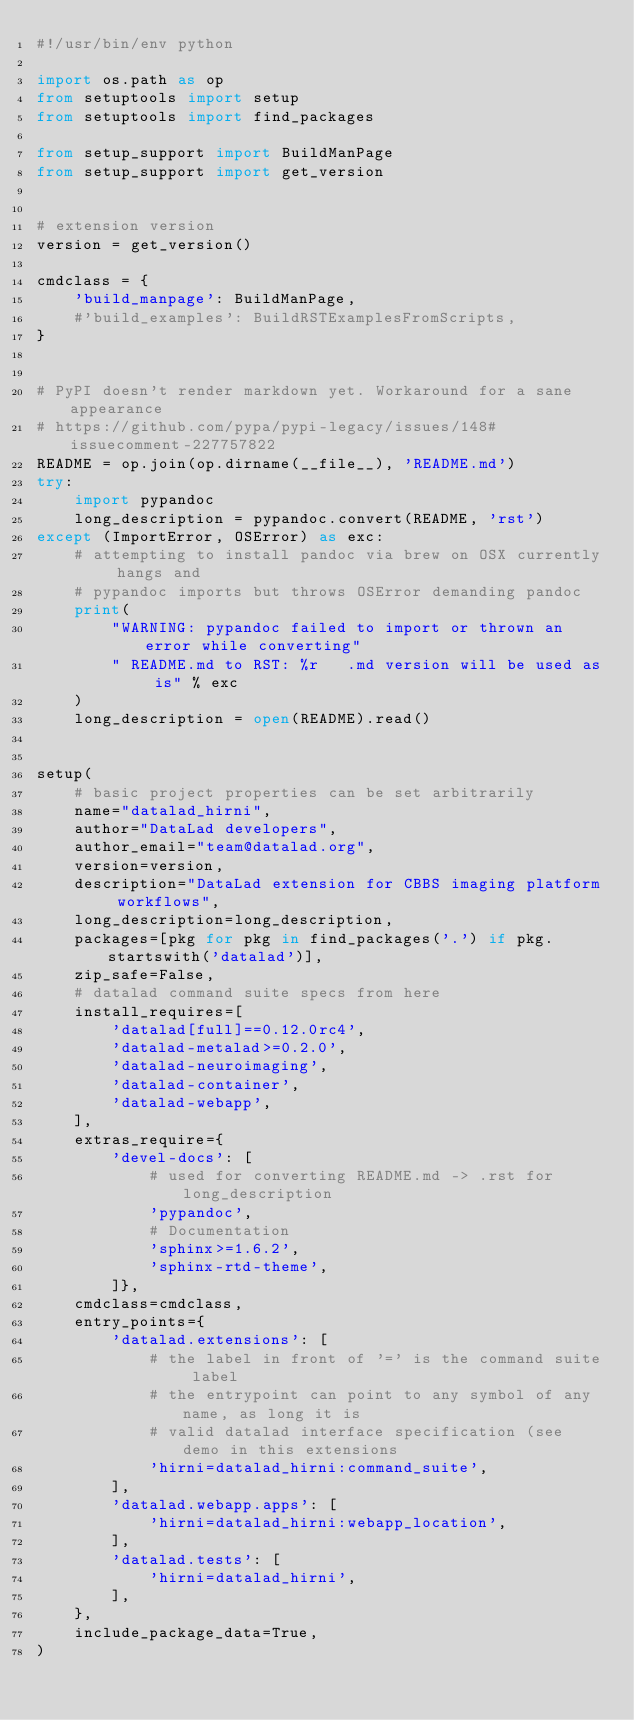Convert code to text. <code><loc_0><loc_0><loc_500><loc_500><_Python_>#!/usr/bin/env python

import os.path as op
from setuptools import setup
from setuptools import find_packages

from setup_support import BuildManPage
from setup_support import get_version


# extension version
version = get_version()

cmdclass = {
    'build_manpage': BuildManPage,
    #'build_examples': BuildRSTExamplesFromScripts,
}


# PyPI doesn't render markdown yet. Workaround for a sane appearance
# https://github.com/pypa/pypi-legacy/issues/148#issuecomment-227757822
README = op.join(op.dirname(__file__), 'README.md')
try:
    import pypandoc
    long_description = pypandoc.convert(README, 'rst')
except (ImportError, OSError) as exc:
    # attempting to install pandoc via brew on OSX currently hangs and
    # pypandoc imports but throws OSError demanding pandoc
    print(
        "WARNING: pypandoc failed to import or thrown an error while converting"
        " README.md to RST: %r   .md version will be used as is" % exc
    )
    long_description = open(README).read()


setup(
    # basic project properties can be set arbitrarily
    name="datalad_hirni",
    author="DataLad developers",
    author_email="team@datalad.org",
    version=version,
    description="DataLad extension for CBBS imaging platform workflows",
    long_description=long_description,
    packages=[pkg for pkg in find_packages('.') if pkg.startswith('datalad')],
    zip_safe=False,
    # datalad command suite specs from here
    install_requires=[
        'datalad[full]==0.12.0rc4',
        'datalad-metalad>=0.2.0',
        'datalad-neuroimaging',
        'datalad-container',
        'datalad-webapp',
    ],
    extras_require={
        'devel-docs': [
            # used for converting README.md -> .rst for long_description
            'pypandoc',
            # Documentation
            'sphinx>=1.6.2',
            'sphinx-rtd-theme',
        ]},
    cmdclass=cmdclass,
    entry_points={
        'datalad.extensions': [
            # the label in front of '=' is the command suite label
            # the entrypoint can point to any symbol of any name, as long it is
            # valid datalad interface specification (see demo in this extensions
            'hirni=datalad_hirni:command_suite',
        ],
        'datalad.webapp.apps': [
            'hirni=datalad_hirni:webapp_location',
        ],
        'datalad.tests': [
            'hirni=datalad_hirni',
        ],
    },
    include_package_data=True,
)
</code> 